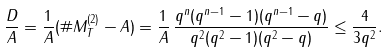Convert formula to latex. <formula><loc_0><loc_0><loc_500><loc_500>\frac { D } { A } = \frac { 1 } { A } ( \# M _ { T } ^ { ( 2 ) } - A ) = \frac { 1 } { A } \, \frac { q ^ { n } ( q ^ { n - 1 } - 1 ) ( q ^ { n - 1 } - q ) } { q ^ { 2 } ( q ^ { 2 } - 1 ) ( q ^ { 2 } - q ) } \leq \frac { 4 } { 3 q ^ { 2 } } .</formula> 